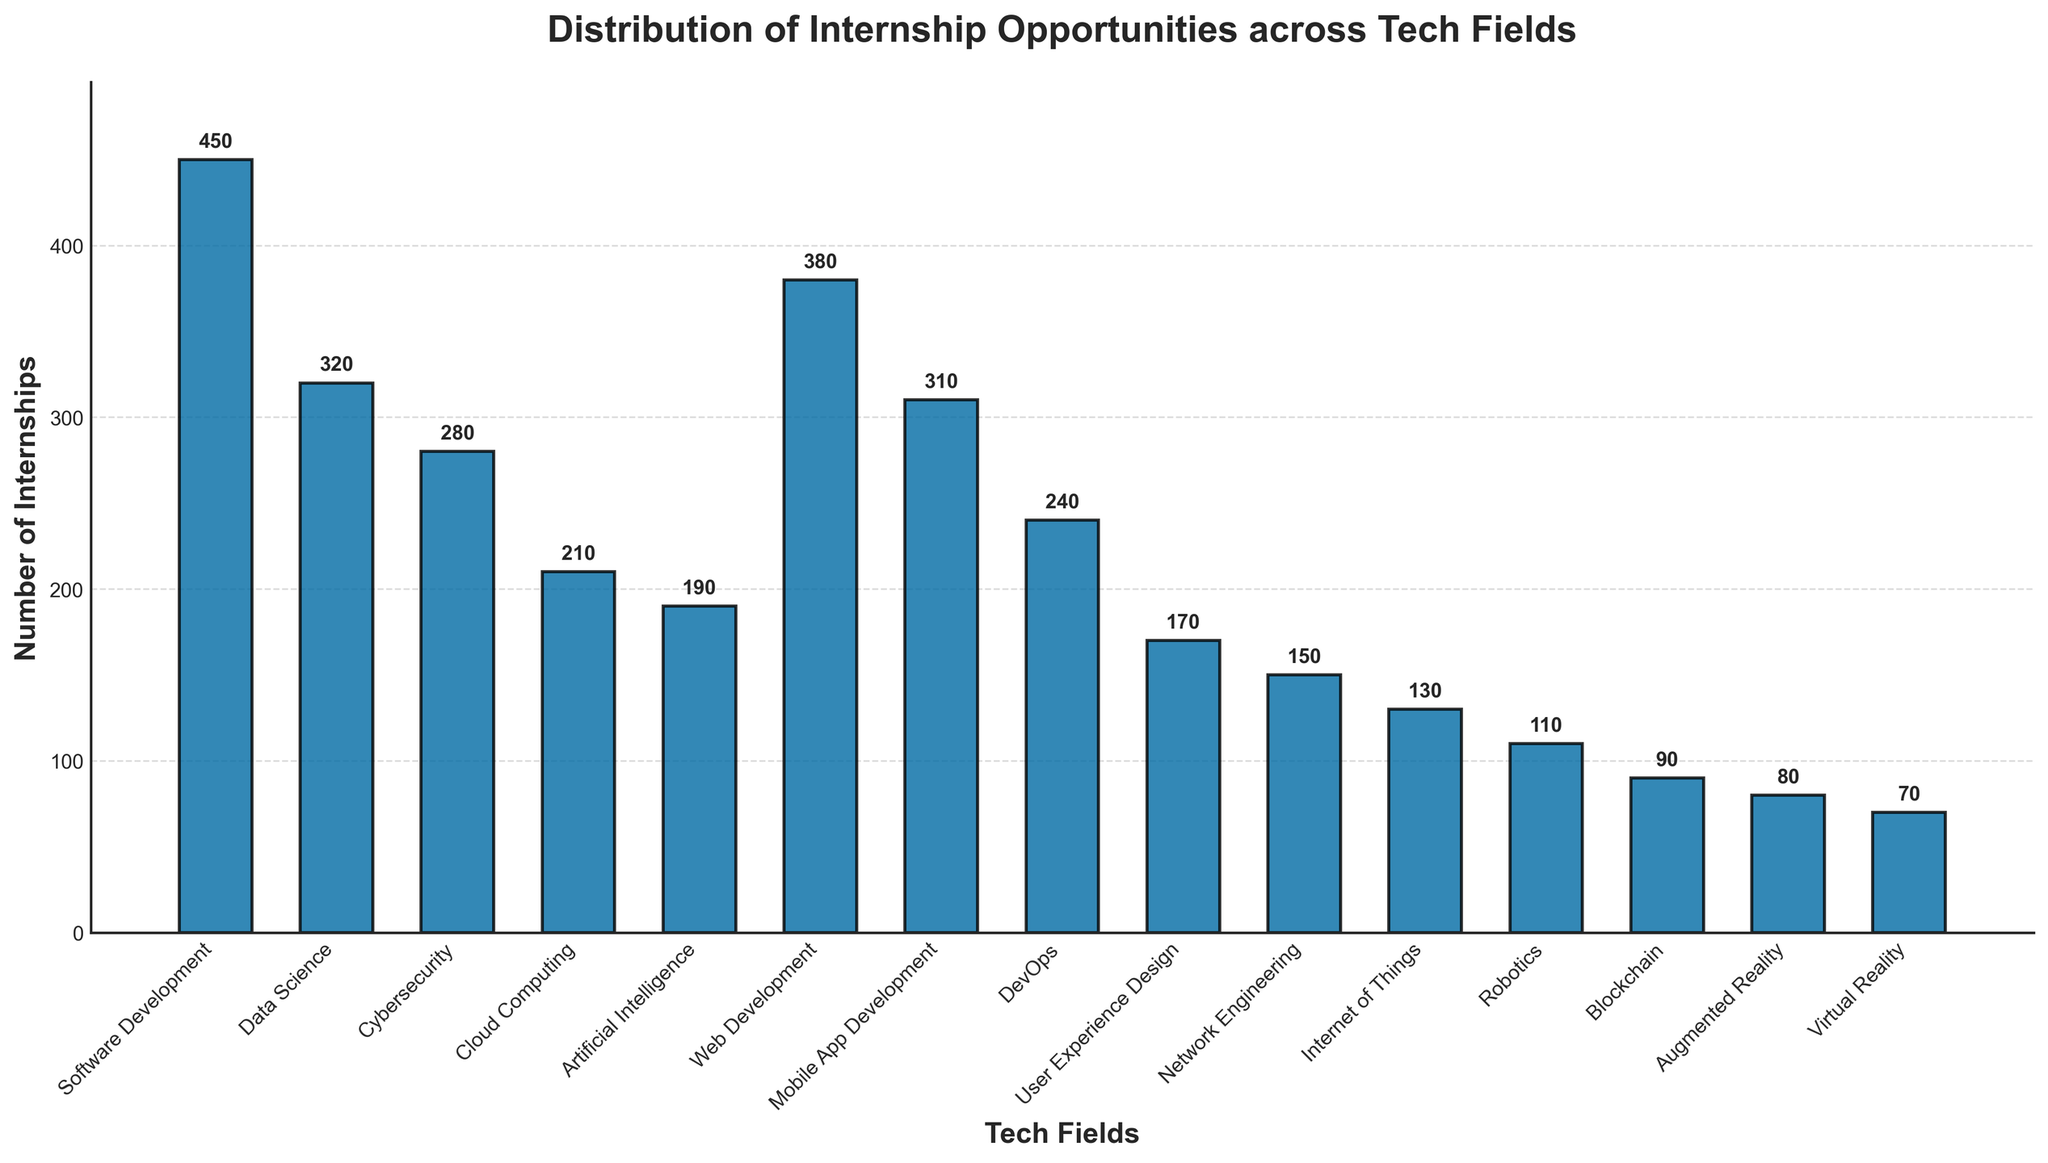Which tech field has the most internship opportunities? First, identify the tech field with the tallest bar in the bar chart. The tallest bar represents Software Development and has a value of 450.
Answer: Software Development What's the difference in the number of internships between Software Development and Artificial Intelligence? Look at the heights for Software Development (450) and Artificial Intelligence (190). Subtract the number of internships for Artificial Intelligence from that of Software Development: 450 - 190 = 260.
Answer: 260 Are there more internship opportunities in Web Development or Data Science? Compare the heights of the bars for Web Development (380) and Data Science (320). The bar for Web Development is taller, meaning it has more internship opportunities.
Answer: Web Development How many internships are offered in fields with over 300 internships? Identify bars with values over 300: Software Development (450), Data Science (320), and Web Development (380). Sum these values: 450 + 320 + 380 = 1150.
Answer: 1150 Which field has fewer internship opportunities, Blockchain or Virtual Reality? Compare the heights of the bars for Blockchain (90) and Virtual Reality (70). The bar for Virtual Reality is shorter, indicating it has fewer internship opportunities.
Answer: Virtual Reality How many more internships are there in Cybersecurity compared to Network Engineering? Find the values for Cybersecurity (280) and Network Engineering (150). Subtract the number of internships for Network Engineering from Cybersecurity: 280 - 150 = 130.
Answer: 130 What is the sum of internships in Cloud Computing and DevOps? Identify the values for Cloud Computing (210) and DevOps (240). Add these values: 210 + 240 = 450.
Answer: 450 How does the number of internships in Mobile App Development compare to Cybersecurity? Look at the values for Mobile App Development (310) and Cybersecurity (280). Mobile App Development has more internships since 310 is greater than 280.
Answer: Mobile App Development Which fields have at least 200 internships each? Identify the bars with values of at least 200: Software Development (450), Data Science (320), Cybersecurity (280), Cloud Computing (210), Web Development (380), Mobile App Development (310), and DevOps (240).
Answer: Software Development, Data Science, Cybersecurity, Cloud Computing, Web Development, Mobile App Development, DevOps 